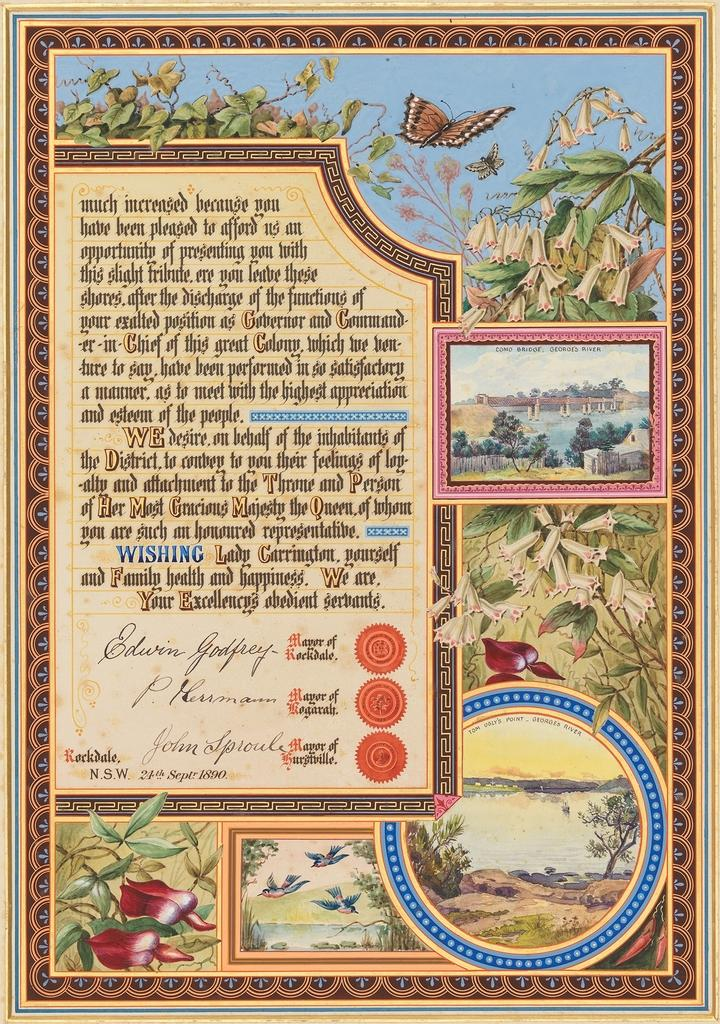<image>
Render a clear and concise summary of the photo. A painting on the poster shows Como Bridge over Georges River 